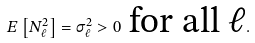<formula> <loc_0><loc_0><loc_500><loc_500>E \left [ N _ { \ell } ^ { 2 } \right ] = \sigma ^ { 2 } _ { \ell } > 0 \ \text {for all $\ell$} .</formula> 